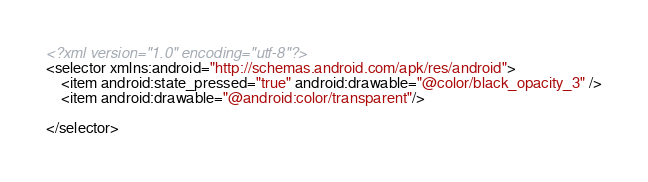<code> <loc_0><loc_0><loc_500><loc_500><_XML_><?xml version="1.0" encoding="utf-8"?>
<selector xmlns:android="http://schemas.android.com/apk/res/android">
    <item android:state_pressed="true" android:drawable="@color/black_opacity_3" />
    <item android:drawable="@android:color/transparent"/>

</selector></code> 